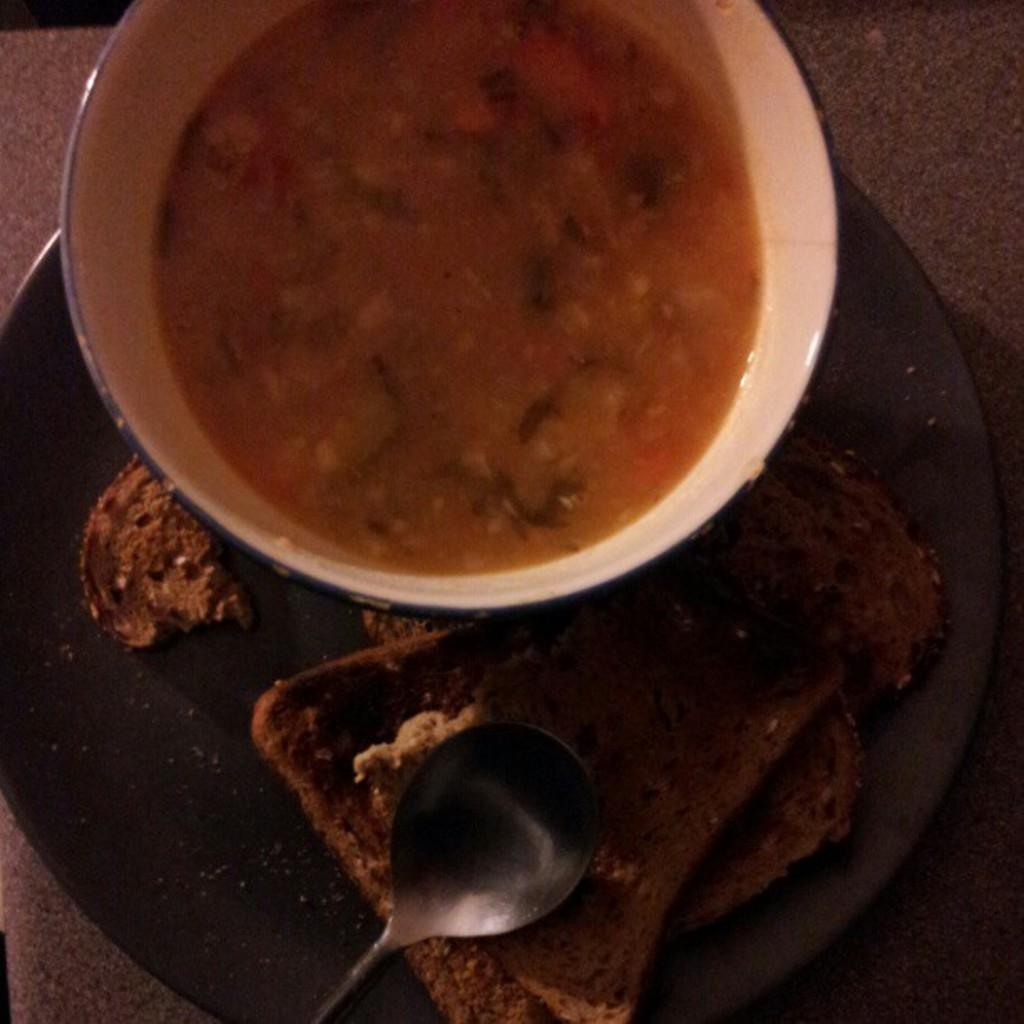What is the main object in the center of the image? There is a plate in the center of the image. What is on the plate? There is bread on the plate. Are there any utensils on the plate? Yes, there is a spoon on the plate. What else can be seen in the image besides the plate? There is a bowl containing food items in the image. How many buttons can be seen on the bread in the image? There are no buttons present on the bread in the image. Are there any spiders crawling on the plate in the image? There are no spiders present in the image. 